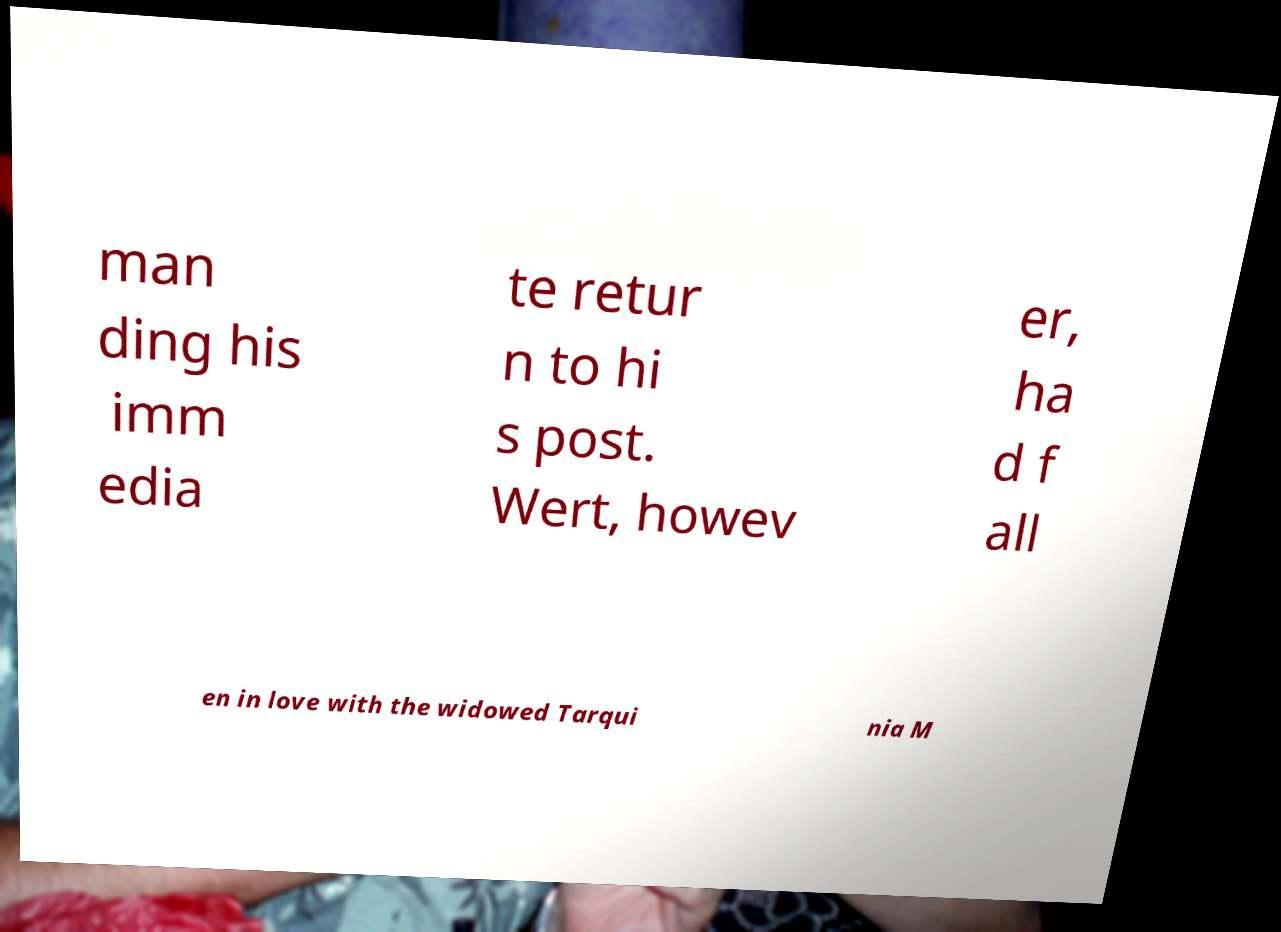Could you assist in decoding the text presented in this image and type it out clearly? man ding his imm edia te retur n to hi s post. Wert, howev er, ha d f all en in love with the widowed Tarqui nia M 